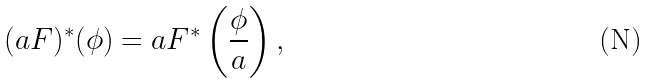Convert formula to latex. <formula><loc_0><loc_0><loc_500><loc_500>( a F ) ^ { * } ( \phi ) = a F ^ { * } \left ( \frac { \phi } { a } \right ) ,</formula> 